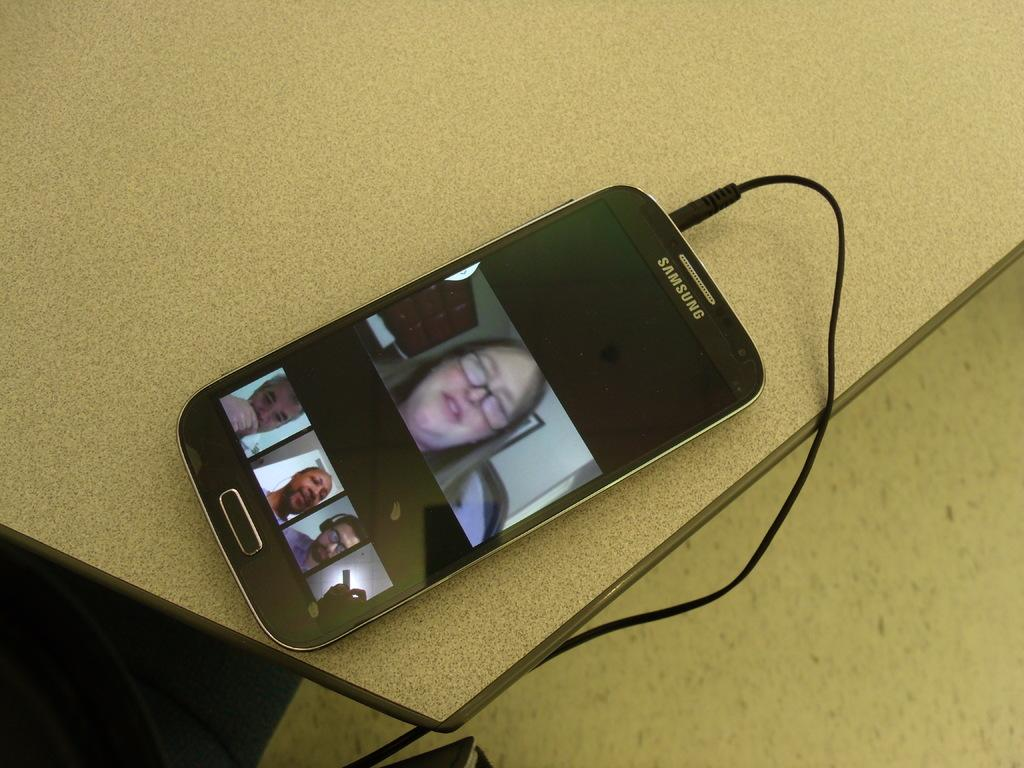Provide a one-sentence caption for the provided image. A samsung phone plugged into a charger with a womans face. 